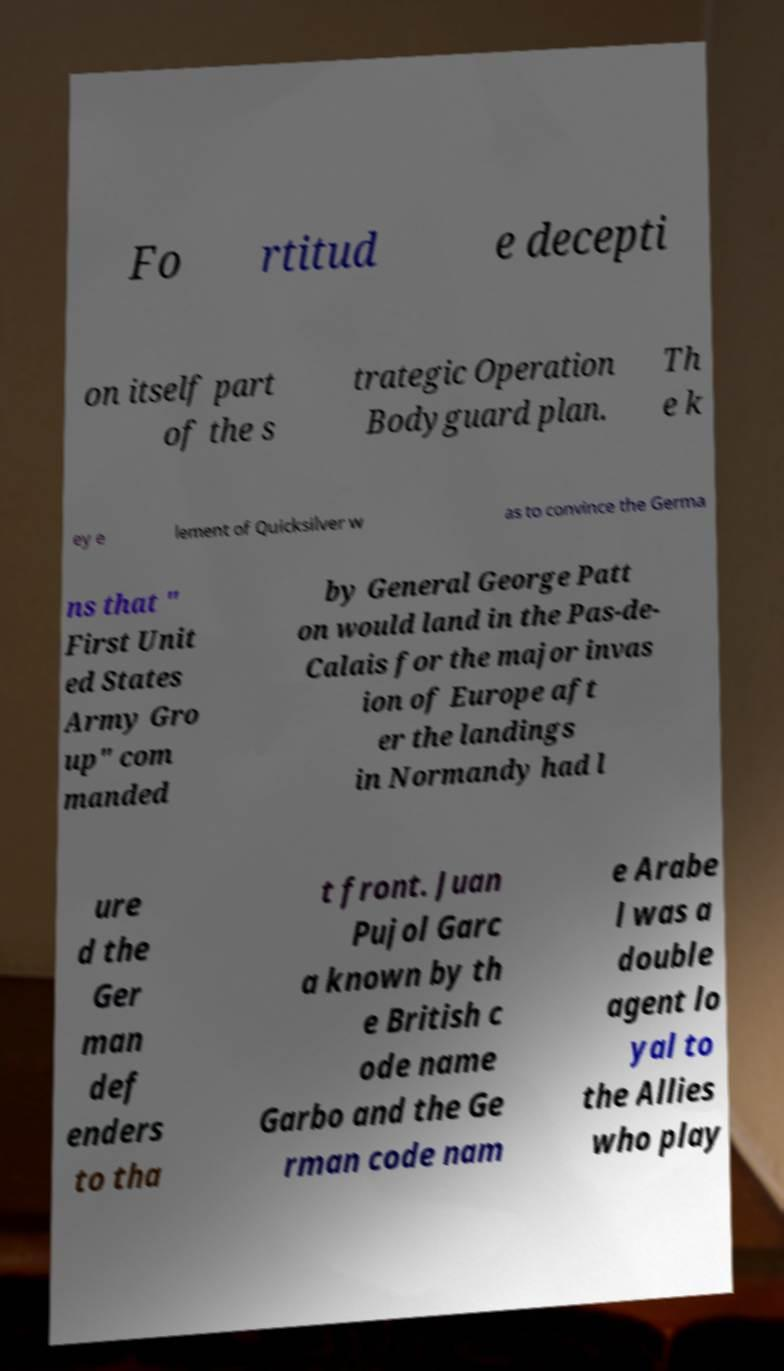There's text embedded in this image that I need extracted. Can you transcribe it verbatim? Fo rtitud e decepti on itself part of the s trategic Operation Bodyguard plan. Th e k ey e lement of Quicksilver w as to convince the Germa ns that " First Unit ed States Army Gro up" com manded by General George Patt on would land in the Pas-de- Calais for the major invas ion of Europe aft er the landings in Normandy had l ure d the Ger man def enders to tha t front. Juan Pujol Garc a known by th e British c ode name Garbo and the Ge rman code nam e Arabe l was a double agent lo yal to the Allies who play 